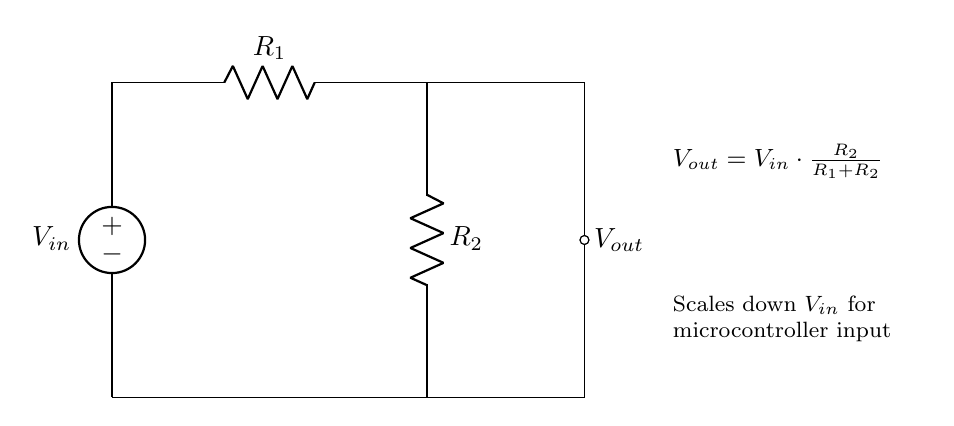What is the input voltage in this circuit? The input voltage is represented by V_in and is connected to the voltage source in the circuit.
Answer: V_in What are the resistor values in the circuit? The resistors in the circuit are labeled R_1 and R_2, but their specific values are not provided in the diagram.
Answer: R_1 and R_2 What is the output voltage expression derived from the circuit? The output voltage, V_out, is given by the formula in the circuit diagram, which states that V_out equals V_in multiplied by the fraction of R_2 over the total resistance R_1 plus R_2.
Answer: V_out = V_in * (R_2 / (R_1 + R_2)) What happens to the output voltage if R_2 is increased? Increasing R_2 increases the output voltage since V_out is directly proportional to R_2 in the voltage divider formula.
Answer: Increases V_out What is the purpose of the voltage divider in this circuit? The voltage divider is designed to scale down the input voltage for use with a microcontroller input, ensuring safe operating levels.
Answer: Scale down input voltage What is the relationship between the resistors and output voltage? The output voltage is dependent on the ratio of the resistors in the voltage divider configuration, specifically the values of R_1 and R_2.
Answer: Output voltage depends on R_1 and R_2 ratio 